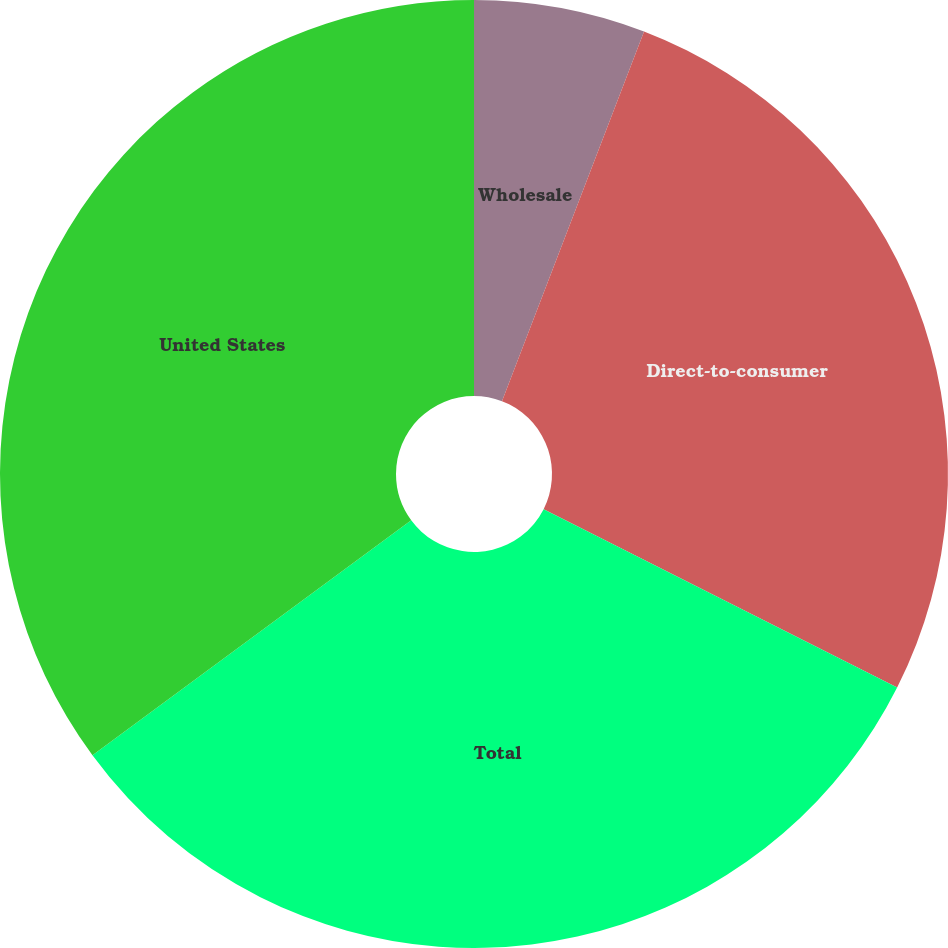Convert chart. <chart><loc_0><loc_0><loc_500><loc_500><pie_chart><fcel>Wholesale<fcel>Direct-to-consumer<fcel>Total<fcel>United States<nl><fcel>5.84%<fcel>26.6%<fcel>32.45%<fcel>35.11%<nl></chart> 